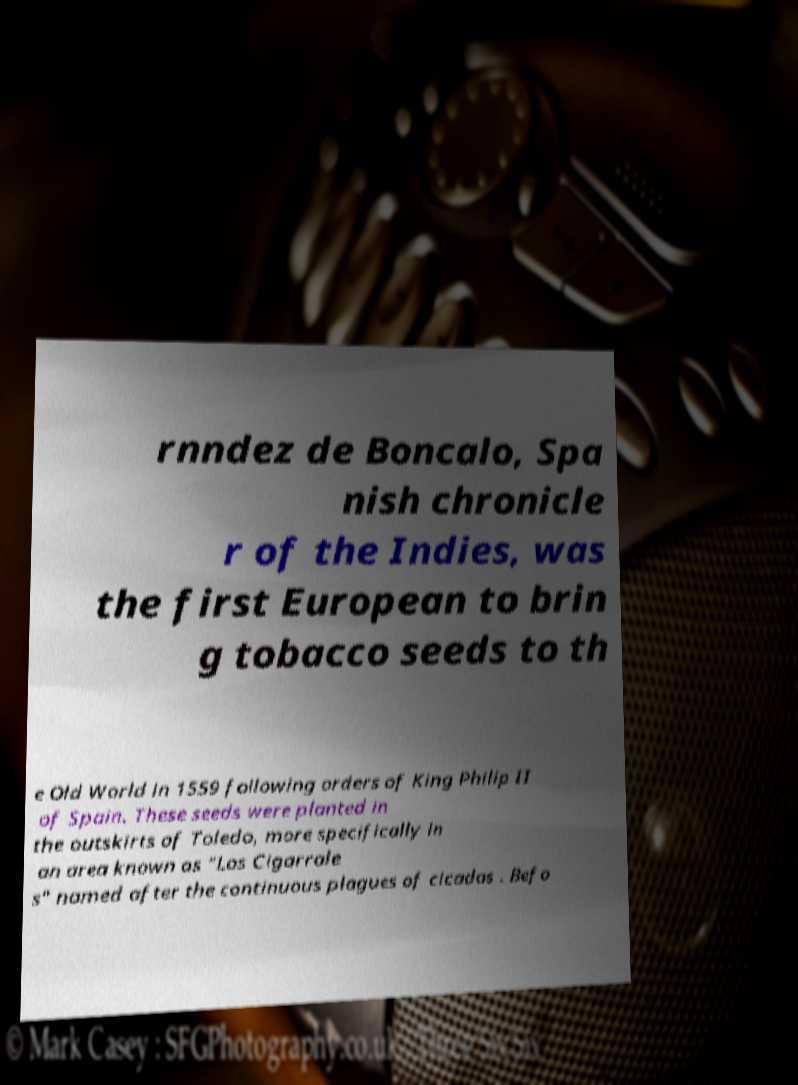Could you assist in decoding the text presented in this image and type it out clearly? rnndez de Boncalo, Spa nish chronicle r of the Indies, was the first European to brin g tobacco seeds to th e Old World in 1559 following orders of King Philip II of Spain. These seeds were planted in the outskirts of Toledo, more specifically in an area known as "Los Cigarrale s" named after the continuous plagues of cicadas . Befo 